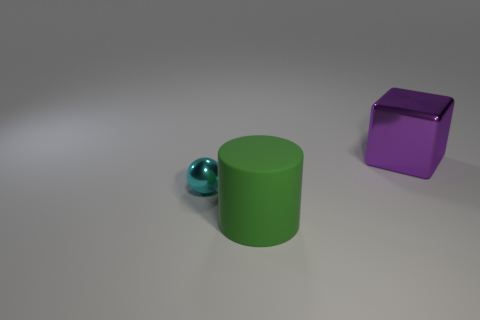Add 3 large purple metallic cylinders. How many objects exist? 6 Subtract all balls. How many objects are left? 2 Subtract all rubber cylinders. Subtract all small cyan shiny things. How many objects are left? 1 Add 1 cubes. How many cubes are left? 2 Add 3 big cubes. How many big cubes exist? 4 Subtract 1 green cylinders. How many objects are left? 2 